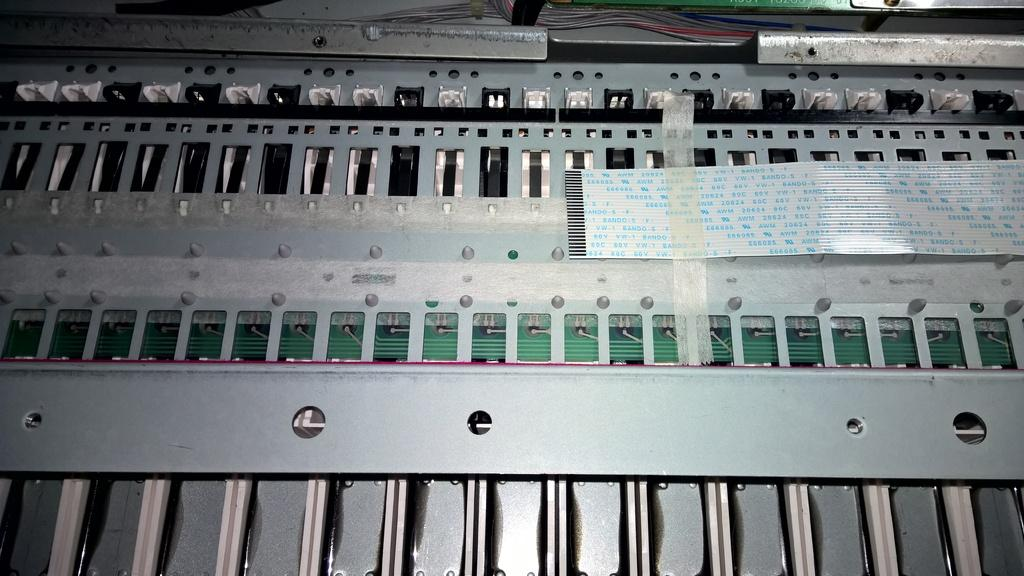What is located in the middle of the image? There are circuits in the middle of the image. What can be seen at the top of the image? There are keyholes at the top of the image. What is present at the bottom of the image? There are keys at the bottom of the image. What type of apparatus is used to care for the deceased in the image? There is no apparatus or reference to death in the image; it features circuits, keyholes, and keys. 